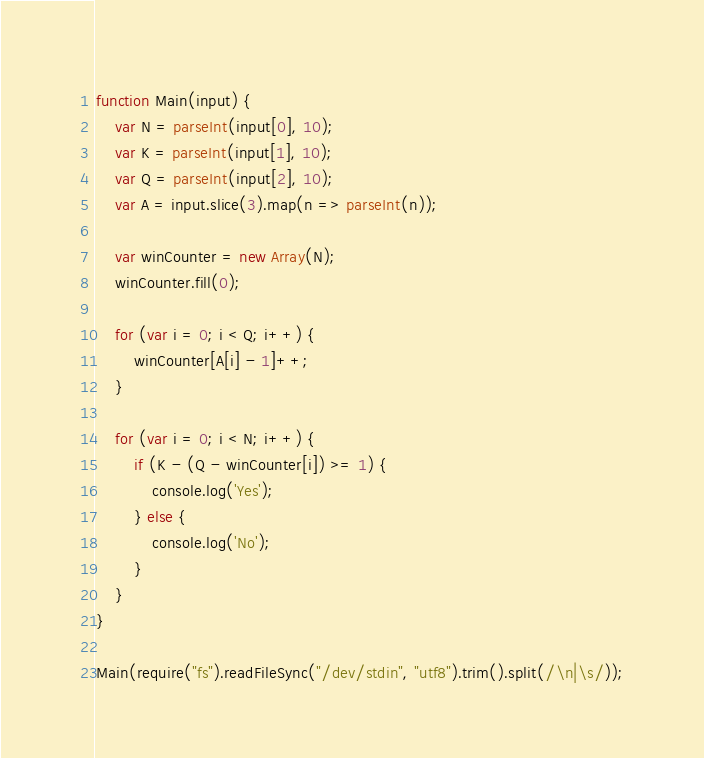<code> <loc_0><loc_0><loc_500><loc_500><_JavaScript_>function Main(input) {
    var N = parseInt(input[0], 10);
    var K = parseInt(input[1], 10);
    var Q = parseInt(input[2], 10);
    var A = input.slice(3).map(n => parseInt(n));

    var winCounter = new Array(N);
    winCounter.fill(0);

    for (var i = 0; i < Q; i++) {
        winCounter[A[i] - 1]++;
    }

    for (var i = 0; i < N; i++) {
        if (K - (Q - winCounter[i]) >= 1) {
            console.log('Yes');
        } else {
            console.log('No');
        }
    }
}

Main(require("fs").readFileSync("/dev/stdin", "utf8").trim().split(/\n|\s/));</code> 